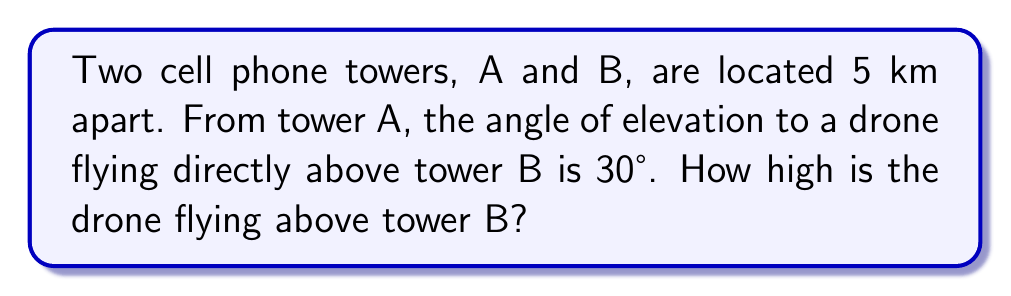Give your solution to this math problem. Let's approach this step-by-step:

1) First, let's visualize the problem:

[asy]
import geometry;

unitsize(1cm);

pair A = (0,0), B = (5,0), C = (5,2.89);
draw(A--B--C--A);
draw(A--B, arrow=Arrow(TeXHead));
draw(B--C, arrow=Arrow(TeXHead));

label("A", A, SW);
label("B", B, SE);
label("C (Drone)", C, NE);
label("5 km", (2.5,0), S);
label("h", (5,1.4), E);
label("30°", (0.5,0.2), NE);

markangle(B, A, C, radius=0.5);
[/asy]

2) We can see that this forms a right-angled triangle. We know:
   - The distance between towers (AB) is 5 km
   - The angle of elevation from A to the drone is 30°
   - We need to find the height of the drone above B (BC)

3) In this right-angled triangle, we can use the tangent function:

   $$ \tan(\theta) = \frac{\text{opposite}}{\text{adjacent}} $$

4) Here, $\theta = 30°$, the opposite side is the height we're looking for (h), and the adjacent side is the distance between towers (5 km):

   $$ \tan(30°) = \frac{h}{5} $$

5) We can rearrange this to solve for h:

   $$ h = 5 \tan(30°) $$

6) We know that $\tan(30°) = \frac{1}{\sqrt{3}}$, so:

   $$ h = 5 \cdot \frac{1}{\sqrt{3}} = \frac{5}{\sqrt{3}} $$

7) Simplifying:

   $$ h = \frac{5\sqrt{3}}{3} \approx 2.89 \text{ km} $$

Therefore, the drone is flying approximately 2.89 km above tower B.
Answer: $\frac{5\sqrt{3}}{3}$ km or approximately 2.89 km 